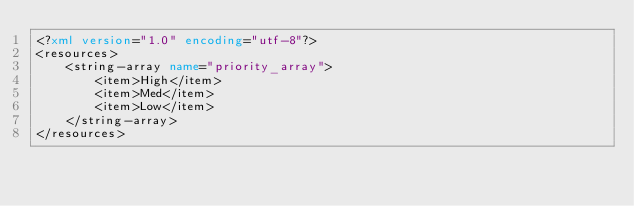<code> <loc_0><loc_0><loc_500><loc_500><_XML_><?xml version="1.0" encoding="utf-8"?>
<resources>
    <string-array name="priority_array">
        <item>High</item>
        <item>Med</item>
        <item>Low</item>
    </string-array>
</resources>
</code> 